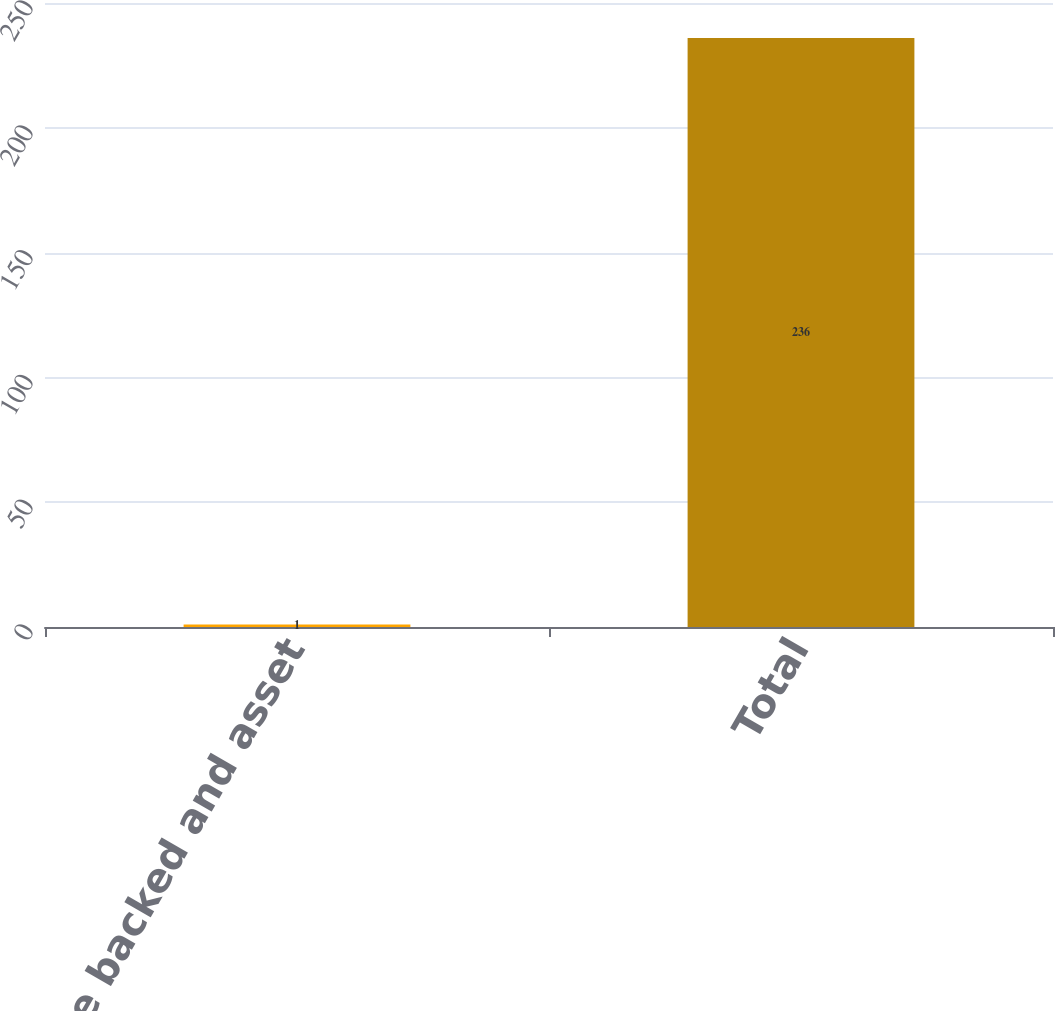Convert chart. <chart><loc_0><loc_0><loc_500><loc_500><bar_chart><fcel>Mortgage backed and asset<fcel>Total<nl><fcel>1<fcel>236<nl></chart> 